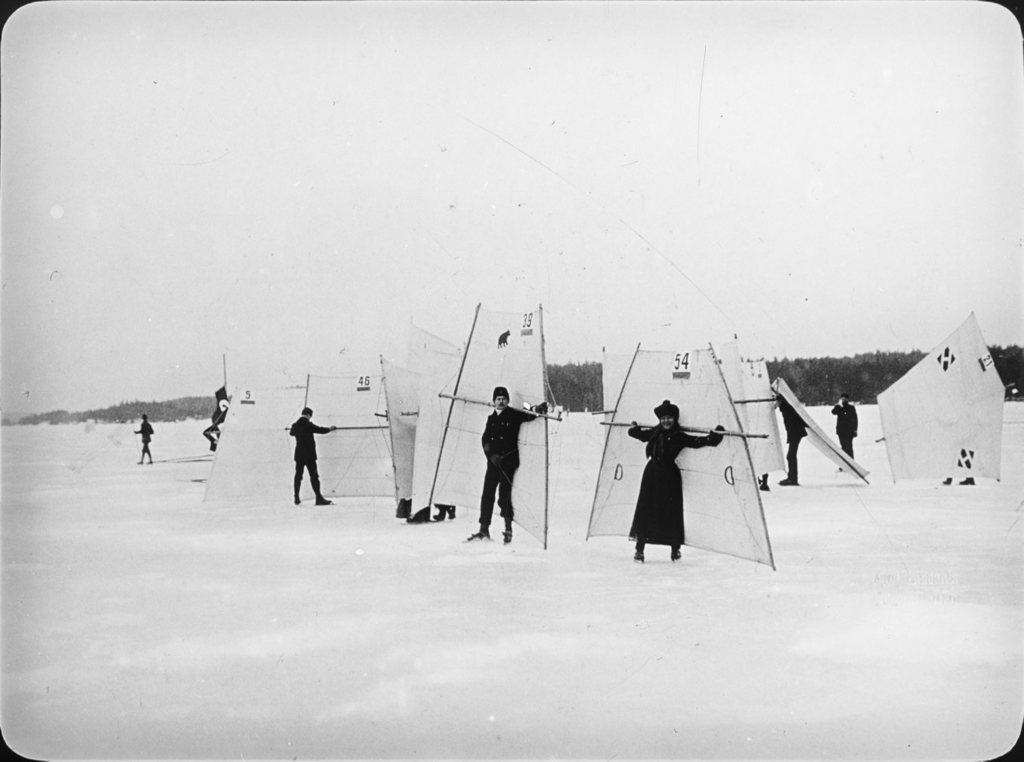How many people are in the image? There are people in the image, but the exact number is not specified. What are the people doing in the image? The people are doing sail skiing in the image. What is the terrain like in the image? The people are on the snow in the image. What can be seen in the background of the image? There are trees and the sky visible in the background of the image. What disease is the person in the image suffering from? There is no indication of any disease in the image; it simply shows people sail skiing on the snow. 